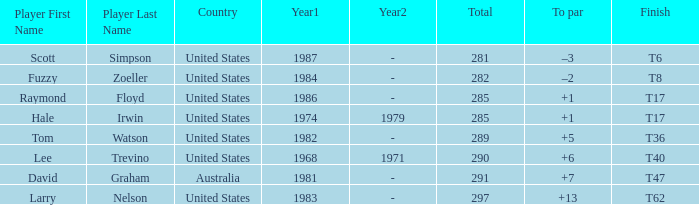What is the year that Hale Irwin won with 285 points? 1974 , 1979. 